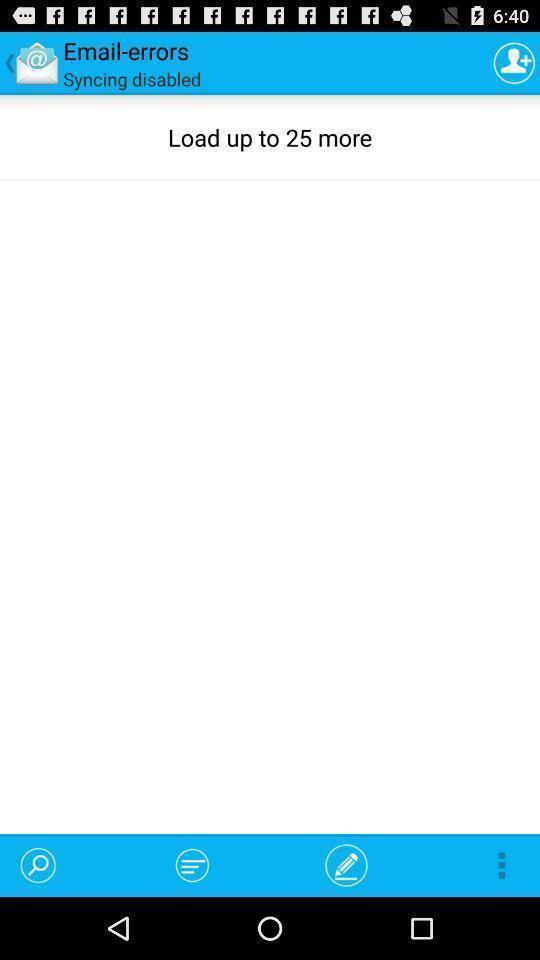Please provide a description for this image. Screen shows to load errors. 